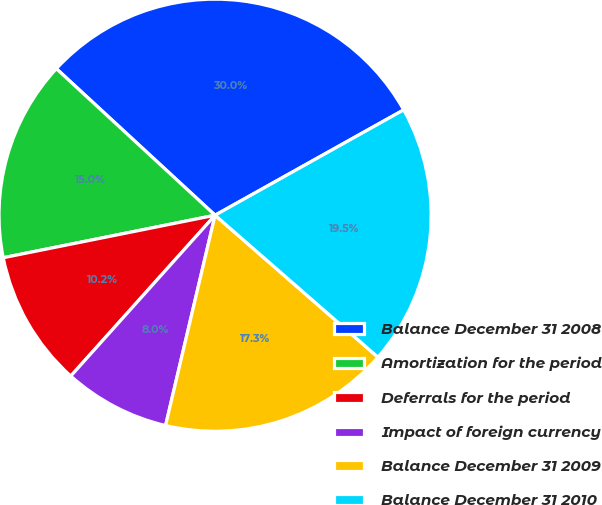<chart> <loc_0><loc_0><loc_500><loc_500><pie_chart><fcel>Balance December 31 2008<fcel>Amortization for the period<fcel>Deferrals for the period<fcel>Impact of foreign currency<fcel>Balance December 31 2009<fcel>Balance December 31 2010<nl><fcel>30.03%<fcel>15.02%<fcel>10.21%<fcel>7.96%<fcel>17.27%<fcel>19.52%<nl></chart> 